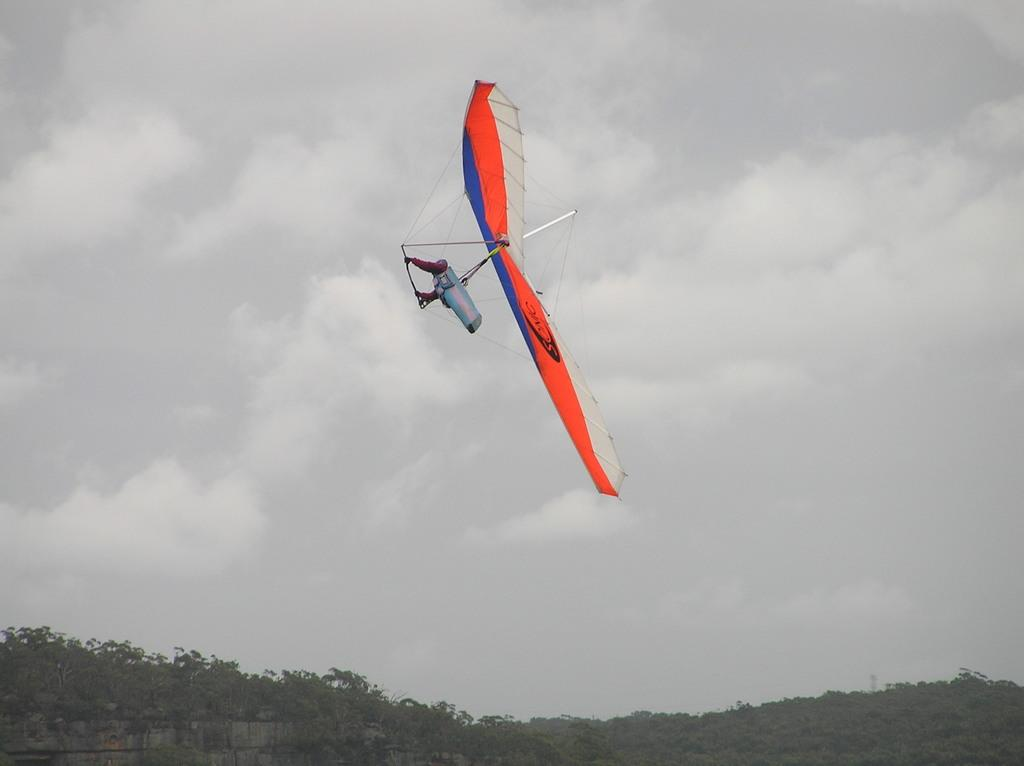What activity is being depicted in the image? There is a hang gliding in the image. What can be seen at the bottom of the image? There are trees and a wall at the bottom of the image. What is visible in the background of the image? The sky is visible in the background of the image. Can you see any railway tracks or roses in the image? No, there are no railway tracks or roses present in the image. What type of connection is established between the hang glider and the trees? There is no direct connection between the hang glider and the trees in the image; they are separate elements. 